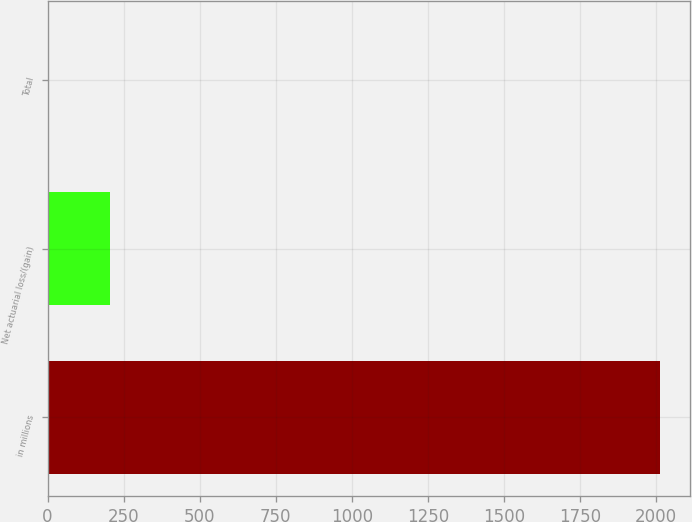<chart> <loc_0><loc_0><loc_500><loc_500><bar_chart><fcel>in millions<fcel>Net actuarial loss/(gain)<fcel>Total<nl><fcel>2011<fcel>204.7<fcel>4<nl></chart> 